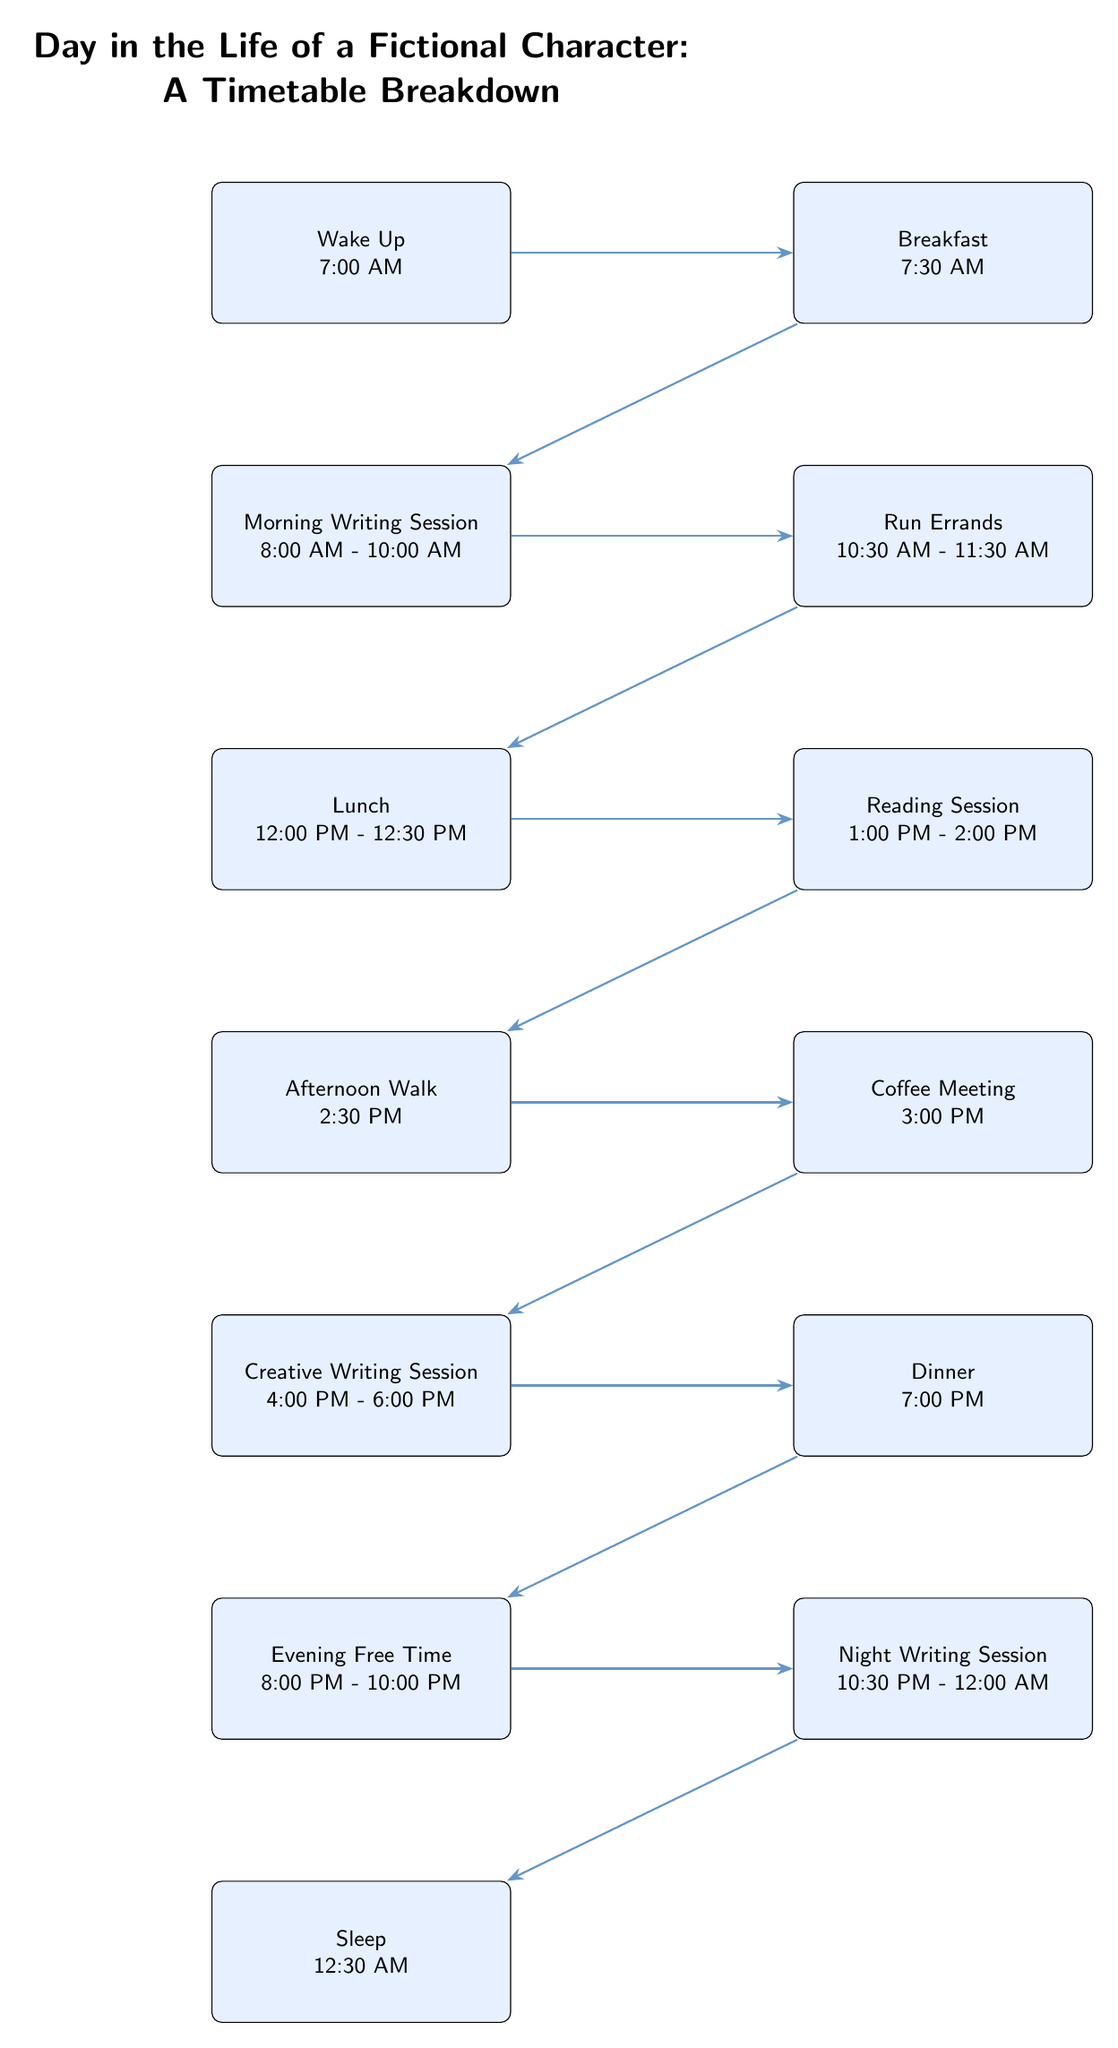What time does the character wake up? The diagram shows the node labeled "Wake Up" with the corresponding time stated as "7:00 AM". This is the first event in the timetable breakdown.
Answer: 7:00 AM What activity follows breakfast? The diagram indicates that after the "Breakfast" node, which is "7:30 AM", the next event is "Morning Writing Session" at "8:00 AM - 10:00 AM".
Answer: Morning Writing Session How long is the Creative Writing Session? The "Creative Writing Session" is listed from "4:00 PM" to "6:00 PM", which is a total duration of 2 hours. By calculating time from start to finish, we confirm this duration.
Answer: 2 hours What is the last activity of the day? Looking at the diagram, the last node is "Sleep", which occurs at "12:30 AM". This indicates that the character goes to sleep at this time.
Answer: Sleep How many writing sessions are there in total? The diagram shows two distinct writing sessions labeled "Morning Writing Session" and "Night Writing Session", summing up to two writing activities throughout the day.
Answer: 2 What time does the Coffee Meeting occur? The "Coffee Meeting" is the node following "Afternoon Walk" and is indicated at "3:00 PM" in the timetable, clearly showing when this activity takes place.
Answer: 3:00 PM Which two activities are adjacent to Lunch? From the diagram, "Run Errands" occurs immediately before "Lunch" at "12:00 PM - 12:30 PM", and "Reading Session" happens immediately after Lunch at "1:00 PM - 2:00 PM". Together, they describe the sequence around the lunch event.
Answer: Run Errands and Reading Session How frequently does the character have sessions for writing? The character has one writing session in the morning and one at night, indicating writing is integrated twice into the day. Thus, it shows that writing occurs regularly during their schedule.
Answer: Twice What precedes and follows the Afternoon Walk? The "Afternoon Walk" follows the "Reading Session" at "1:00 PM - 2:00 PM" and precedes the "Coffee Meeting" at "3:00 PM". By examining the connections, we can clarify the flow of activities around this event.
Answer: Reading Session and Coffee Meeting 